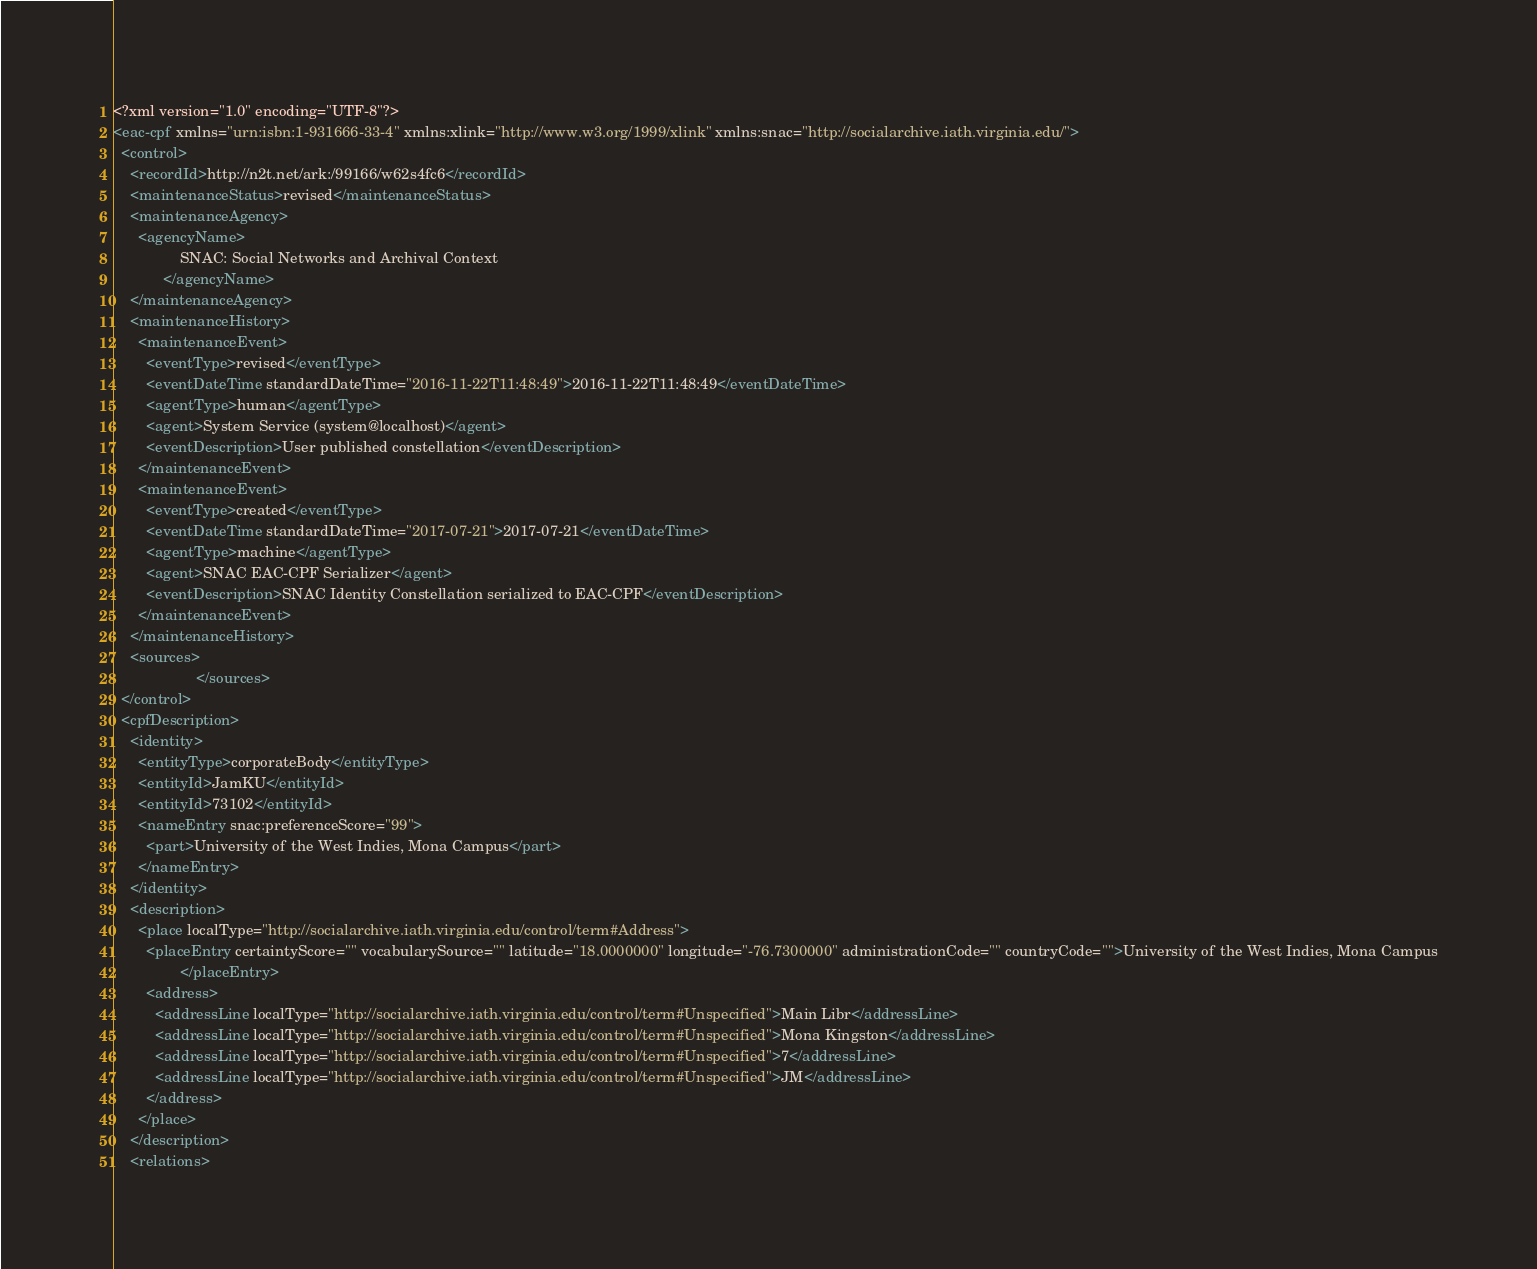Convert code to text. <code><loc_0><loc_0><loc_500><loc_500><_XML_><?xml version="1.0" encoding="UTF-8"?>
<eac-cpf xmlns="urn:isbn:1-931666-33-4" xmlns:xlink="http://www.w3.org/1999/xlink" xmlns:snac="http://socialarchive.iath.virginia.edu/">
  <control>
    <recordId>http://n2t.net/ark:/99166/w62s4fc6</recordId>
    <maintenanceStatus>revised</maintenanceStatus>
    <maintenanceAgency>
      <agencyName>
                SNAC: Social Networks and Archival Context
            </agencyName>
    </maintenanceAgency>
    <maintenanceHistory>
      <maintenanceEvent>
        <eventType>revised</eventType>
        <eventDateTime standardDateTime="2016-11-22T11:48:49">2016-11-22T11:48:49</eventDateTime>
        <agentType>human</agentType>
        <agent>System Service (system@localhost)</agent>
        <eventDescription>User published constellation</eventDescription>
      </maintenanceEvent>
      <maintenanceEvent>
        <eventType>created</eventType>
        <eventDateTime standardDateTime="2017-07-21">2017-07-21</eventDateTime>
        <agentType>machine</agentType>
        <agent>SNAC EAC-CPF Serializer</agent>
        <eventDescription>SNAC Identity Constellation serialized to EAC-CPF</eventDescription>
      </maintenanceEvent>
    </maintenanceHistory>
    <sources>
                    </sources>
  </control>
  <cpfDescription>
    <identity>
      <entityType>corporateBody</entityType>
      <entityId>JamKU</entityId>
      <entityId>73102</entityId>
      <nameEntry snac:preferenceScore="99">
        <part>University of the West Indies, Mona Campus</part>
      </nameEntry>
    </identity>
    <description>
      <place localType="http://socialarchive.iath.virginia.edu/control/term#Address">
        <placeEntry certaintyScore="" vocabularySource="" latitude="18.0000000" longitude="-76.7300000" administrationCode="" countryCode="">University of the West Indies, Mona Campus
                </placeEntry>
        <address>
          <addressLine localType="http://socialarchive.iath.virginia.edu/control/term#Unspecified">Main Libr</addressLine>
          <addressLine localType="http://socialarchive.iath.virginia.edu/control/term#Unspecified">Mona Kingston</addressLine>
          <addressLine localType="http://socialarchive.iath.virginia.edu/control/term#Unspecified">7</addressLine>
          <addressLine localType="http://socialarchive.iath.virginia.edu/control/term#Unspecified">JM</addressLine>
        </address>
      </place>
    </description>
    <relations></code> 